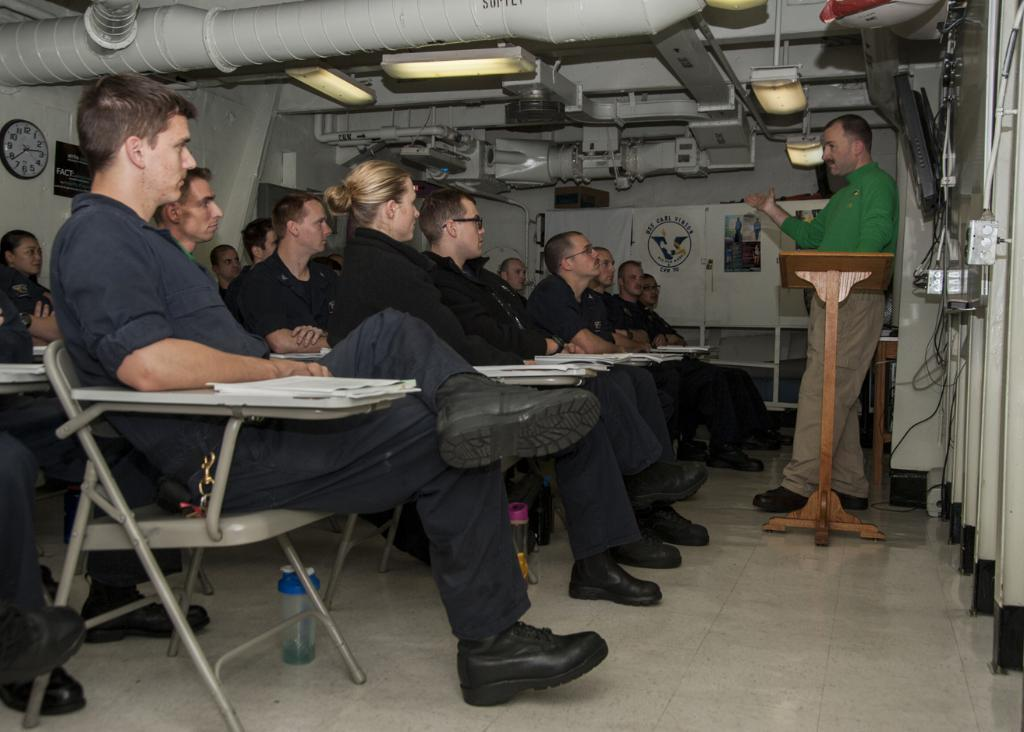What are the people in the image doing? The people in the image are sitting on chairs. Can you describe the man in the image? There is a man standing in the image. What can be seen on the wall in the image? There is a clock on the wall in the image. What type of structure is visible in the image? There is a pipe line visible in the image. What type of plastic item is being used by the people sitting on chairs in the image? There is no plastic item being used by the people sitting on chairs in the image. 